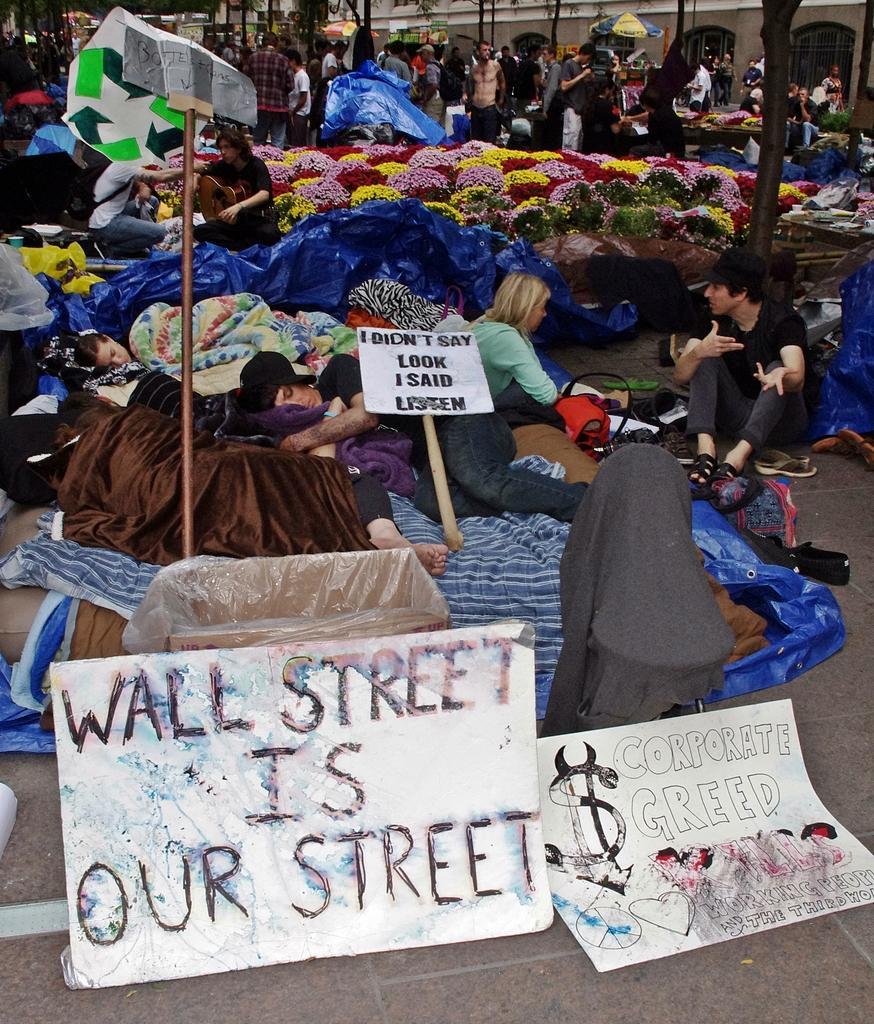In one or two sentences, can you explain what this image depicts? In this image we can see people sitting on the road and some of them are lying. there are blankets and boards. in the background there is a building. at the bottom there are boards and we can see flowers. 